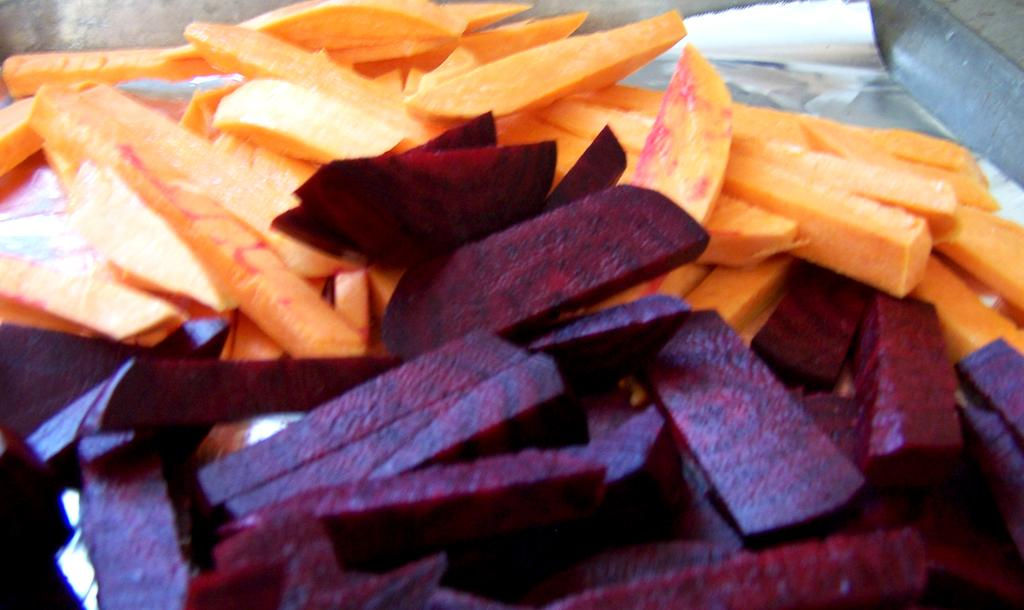What type of vegetable is chopped and visible in the image? There is chopped beetroot in the image. What other vegetable is chopped and visible in the image? There is chopped carrot in the image. What type of prison can be seen in the image? There is no prison present in the image; it features chopped beetroot and carrot. What color is the lipstick on the blade in the image? There is no blade or lipstick present in the image. 